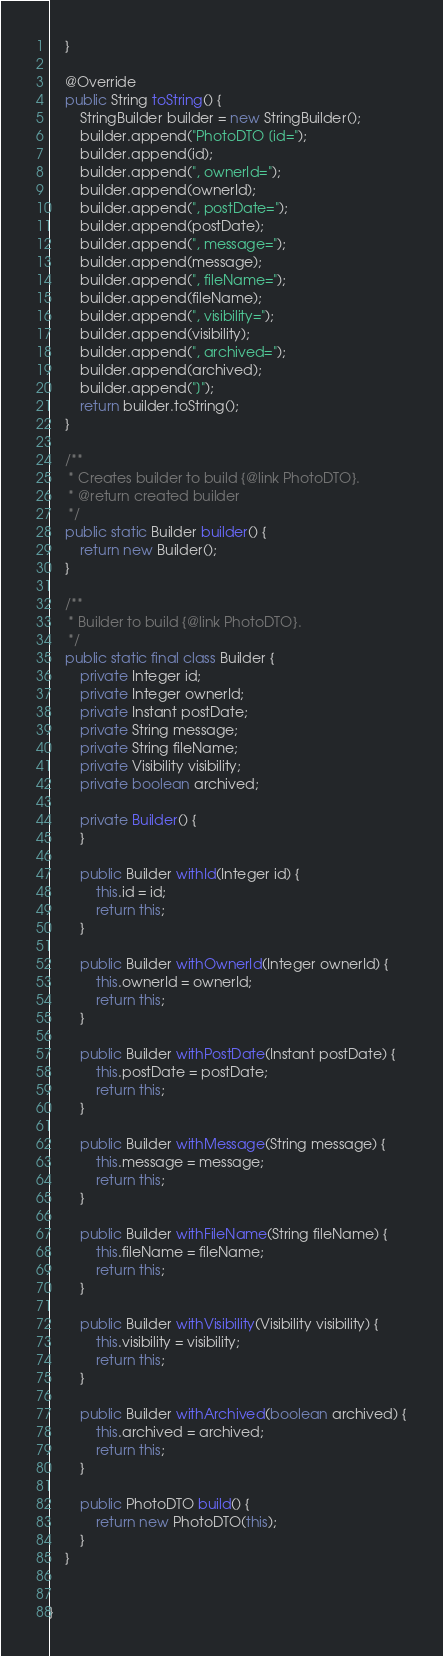<code> <loc_0><loc_0><loc_500><loc_500><_Java_>	}

	@Override
	public String toString() {
		StringBuilder builder = new StringBuilder();
		builder.append("PhotoDTO [id=");
		builder.append(id);
		builder.append(", ownerId=");
		builder.append(ownerId);
		builder.append(", postDate=");
		builder.append(postDate);
		builder.append(", message=");
		builder.append(message);
		builder.append(", fileName=");
		builder.append(fileName);
		builder.append(", visibility=");
		builder.append(visibility);
		builder.append(", archived=");
		builder.append(archived);
		builder.append("]");
		return builder.toString();
	}

	/**
	 * Creates builder to build {@link PhotoDTO}.
	 * @return created builder
	 */
	public static Builder builder() {
		return new Builder();
	}

	/**
	 * Builder to build {@link PhotoDTO}.
	 */
	public static final class Builder {
		private Integer id;
		private Integer ownerId;
		private Instant postDate;
		private String message;
		private String fileName;
		private Visibility visibility;
		private boolean archived;

		private Builder() {
		}

		public Builder withId(Integer id) {
			this.id = id;
			return this;
		}

		public Builder withOwnerId(Integer ownerId) {
			this.ownerId = ownerId;
			return this;
		}

		public Builder withPostDate(Instant postDate) {
			this.postDate = postDate;
			return this;
		}

		public Builder withMessage(String message) {
			this.message = message;
			return this;
		}

		public Builder withFileName(String fileName) {
			this.fileName = fileName;
			return this;
		}

		public Builder withVisibility(Visibility visibility) {
			this.visibility = visibility;
			return this;
		}

		public Builder withArchived(boolean archived) {
			this.archived = archived;
			return this;
		}

		public PhotoDTO build() {
			return new PhotoDTO(this);
		}
	}

	
}
</code> 